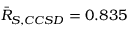<formula> <loc_0><loc_0><loc_500><loc_500>\bar { R } _ { S , C C S D } = 0 . 8 3 5</formula> 